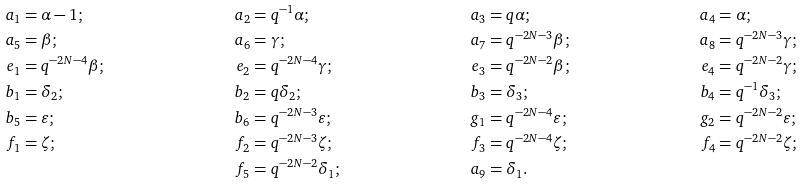Convert formula to latex. <formula><loc_0><loc_0><loc_500><loc_500>a _ { 1 } & = \alpha - 1 ; & a _ { 2 } & = q ^ { - 1 } \alpha ; & a _ { 3 } & = q \alpha ; & a _ { 4 } & = \alpha ; \\ a _ { 5 } & = \beta ; & a _ { 6 } & = \gamma ; & a _ { 7 } & = q ^ { - 2 N - 3 } \beta ; & a _ { 8 } & = q ^ { - 2 N - 3 } \gamma ; \\ e _ { 1 } & = q ^ { - 2 N - 4 } \beta ; & e _ { 2 } & = q ^ { - 2 N - 4 } \gamma ; & e _ { 3 } & = q ^ { - 2 N - 2 } \beta ; & e _ { 4 } & = q ^ { - 2 N - 2 } \gamma ; \\ b _ { 1 } & = \delta _ { 2 } ; & b _ { 2 } & = q \delta _ { 2 } ; & b _ { 3 } & = \delta _ { 3 } ; & b _ { 4 } & = q ^ { - 1 } \delta _ { 3 } ; \\ b _ { 5 } & = \varepsilon ; & b _ { 6 } & = q ^ { - 2 N - 3 } \varepsilon ; & g _ { 1 } & = q ^ { - 2 N - 4 } \varepsilon ; & g _ { 2 } & = q ^ { - 2 N - 2 } \varepsilon ; \\ f _ { 1 } & = \zeta ; & f _ { 2 } & = q ^ { - 2 N - 3 } \zeta ; & f _ { 3 } & = q ^ { - 2 N - 4 } \zeta ; & f _ { 4 } & = q ^ { - 2 N - 2 } \zeta ; \\ & & f _ { 5 } & = q ^ { - 2 N - 2 } \delta _ { 1 } ; & a _ { 9 } & = \delta _ { 1 } . & &</formula> 